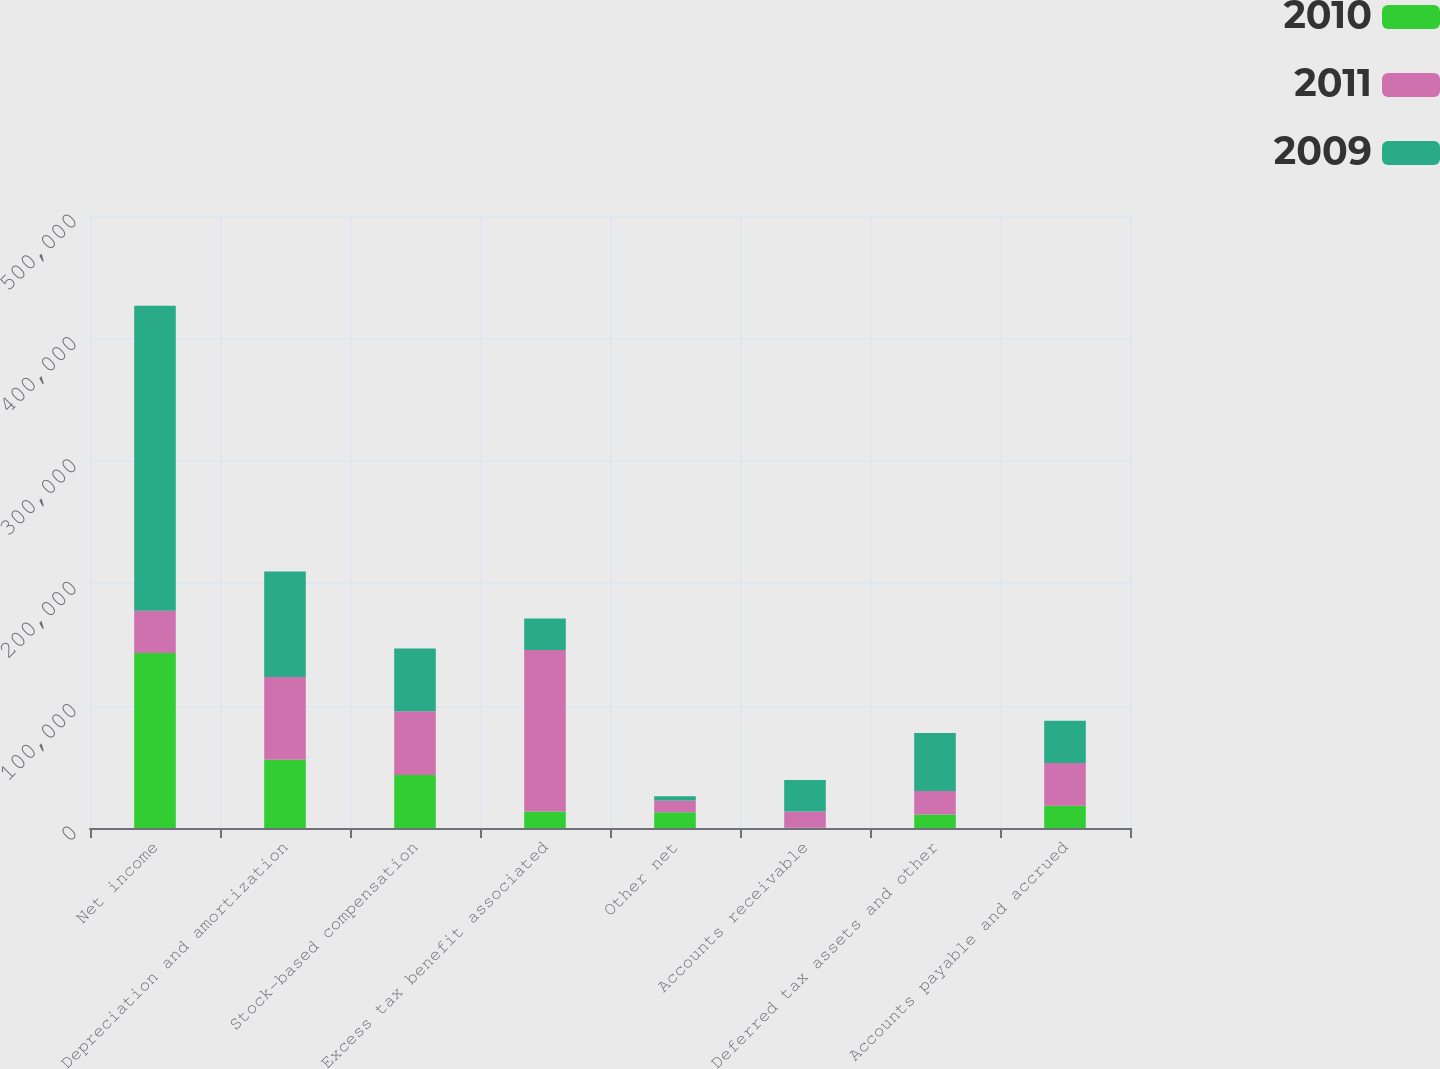Convert chart. <chart><loc_0><loc_0><loc_500><loc_500><stacked_bar_chart><ecel><fcel>Net income<fcel>Depreciation and amortization<fcel>Stock-based compensation<fcel>Excess tax benefit associated<fcel>Other net<fcel>Accounts receivable<fcel>Deferred tax assets and other<fcel>Accounts payable and accrued<nl><fcel>2010<fcel>142891<fcel>55706<fcel>43272<fcel>13420<fcel>12965<fcel>251<fcel>11043<fcel>18162<nl><fcel>2011<fcel>34545<fcel>67655<fcel>52178<fcel>131926<fcel>9474<fcel>13147<fcel>19105<fcel>34952<nl><fcel>2009<fcel>249239<fcel>86266<fcel>51166<fcel>25880<fcel>3567<fcel>25798<fcel>47418<fcel>34545<nl></chart> 